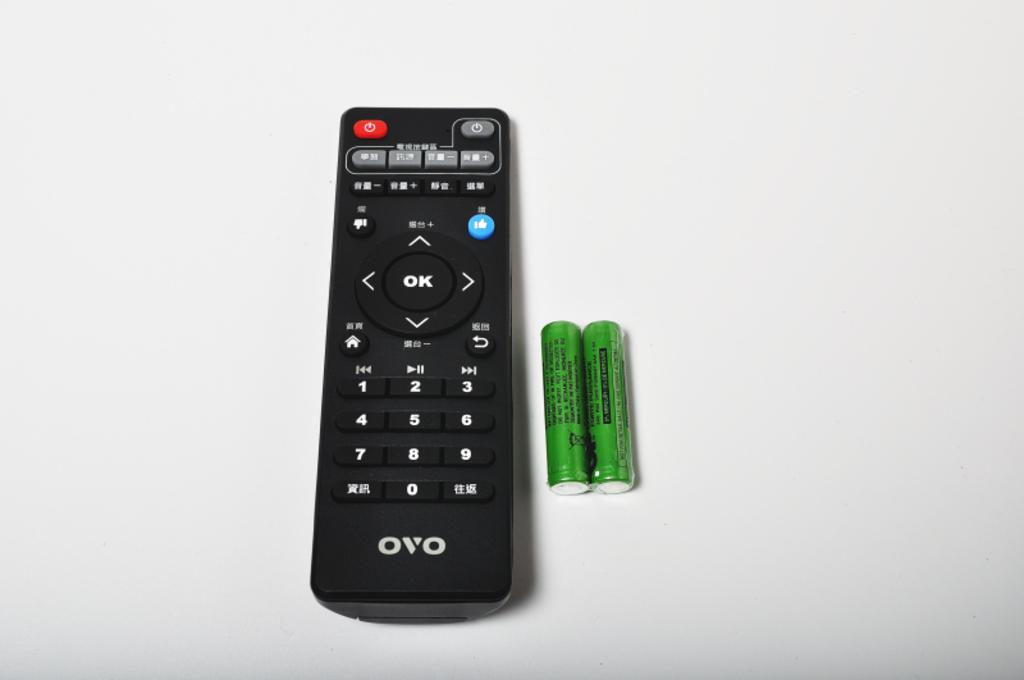Provide a one-sentence caption for the provided image. An OVO brand remote sits alongside two batteries. 